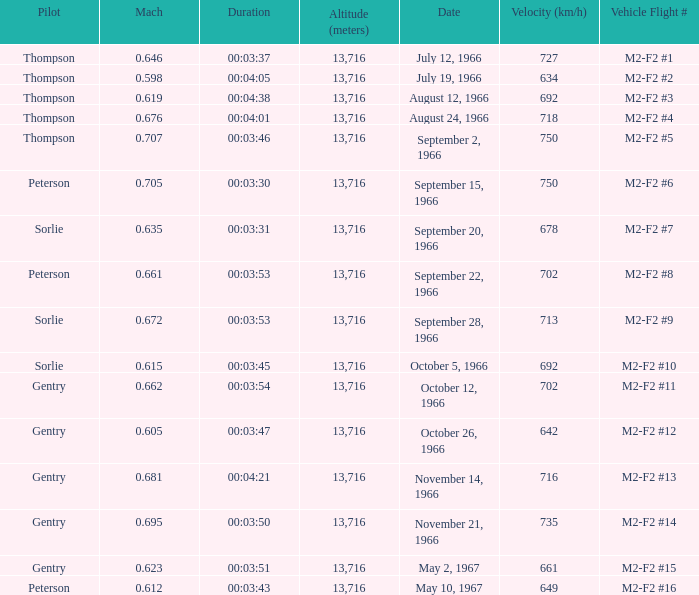What Vehicle Flight # has Pilot Peterson and Velocity (km/h) of 649? M2-F2 #16. 